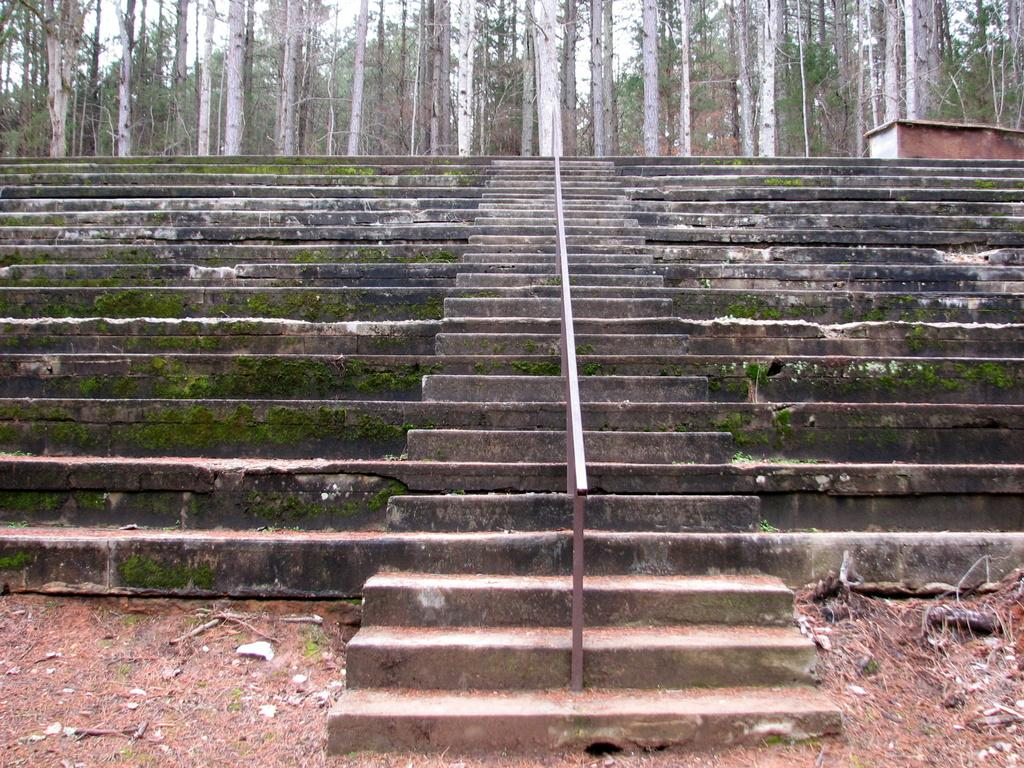What type of structure can be seen in the image? There are stairs in the image, extending from left to right. What is visible in the background of the image? There is a house and trees in the background of the image. What type of string can be seen connecting the trees in the image? There is no string connecting the trees in the image; only the house and trees are present in the background. 